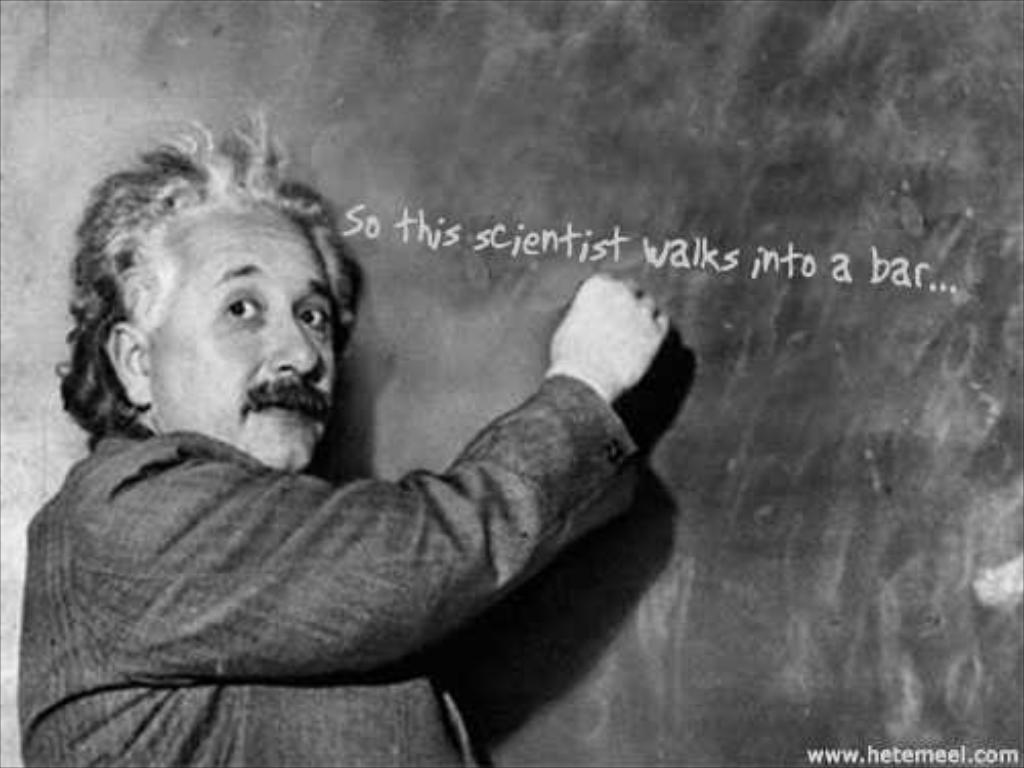Who is the main subject in the image? There is a person in the image. What is the person doing in the image? The person is writing on a black color board. How many chickens are present in the image? There are no chickens present in the image; it features a person writing on a black color board. 